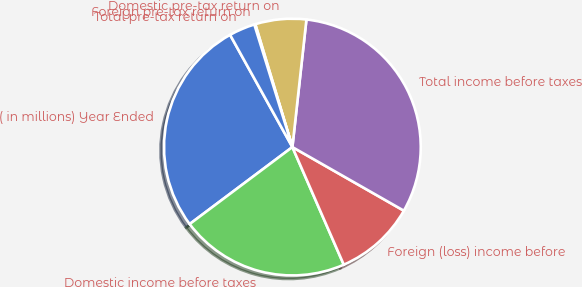<chart> <loc_0><loc_0><loc_500><loc_500><pie_chart><fcel>( in millions) Year Ended<fcel>Domestic income before taxes<fcel>Foreign (loss) income before<fcel>Total income before taxes<fcel>Domestic pre-tax return on<fcel>Foreign pre-tax return on<fcel>Total pre-tax return on<nl><fcel>27.17%<fcel>21.32%<fcel>10.19%<fcel>31.51%<fcel>6.41%<fcel>0.13%<fcel>3.27%<nl></chart> 